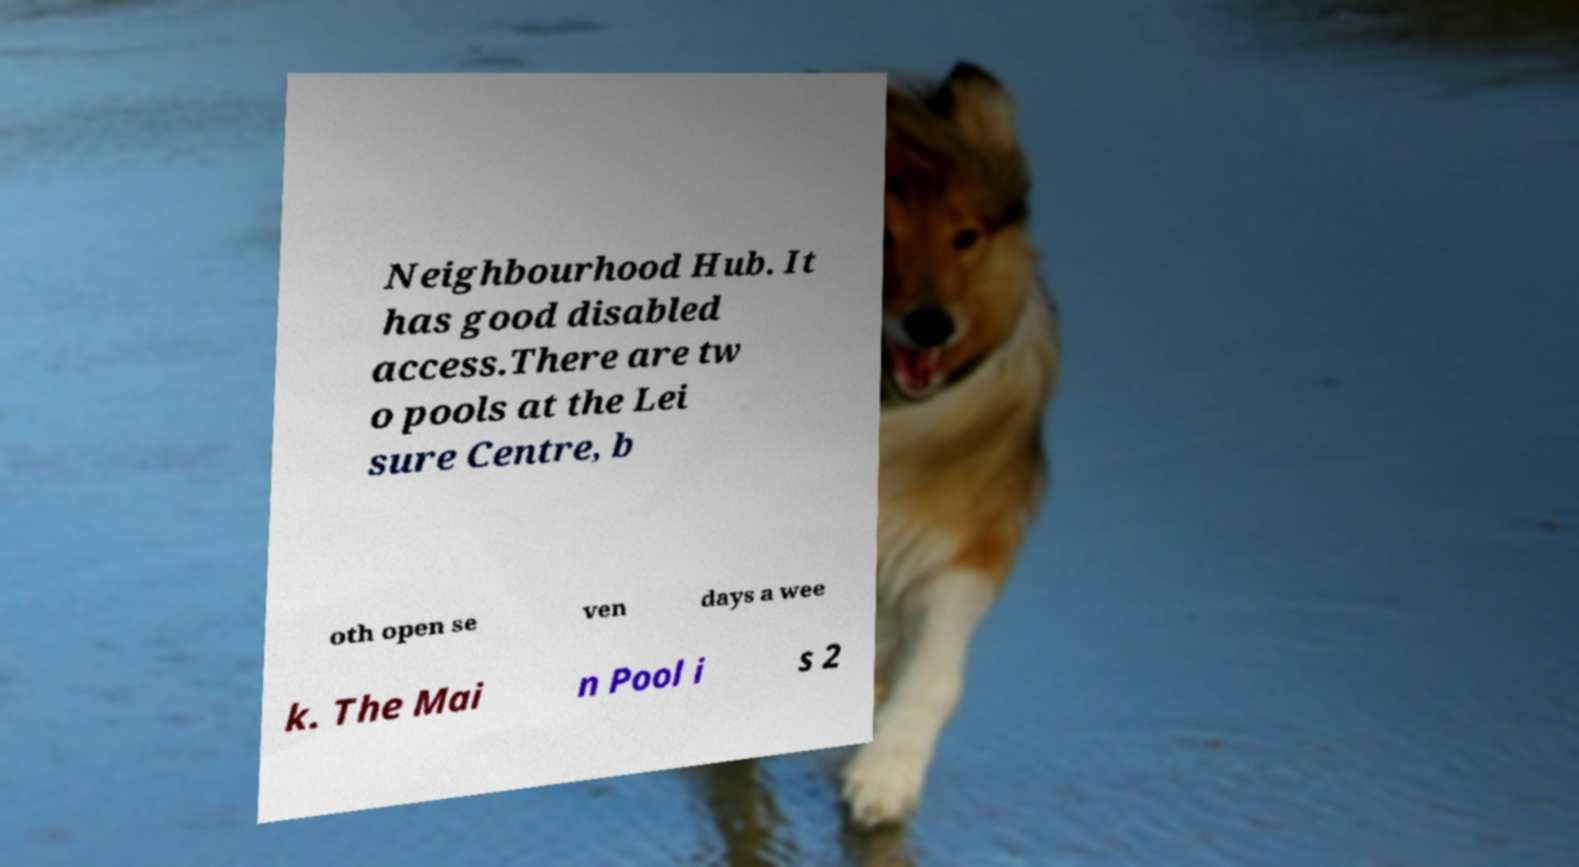Please read and relay the text visible in this image. What does it say? Neighbourhood Hub. It has good disabled access.There are tw o pools at the Lei sure Centre, b oth open se ven days a wee k. The Mai n Pool i s 2 